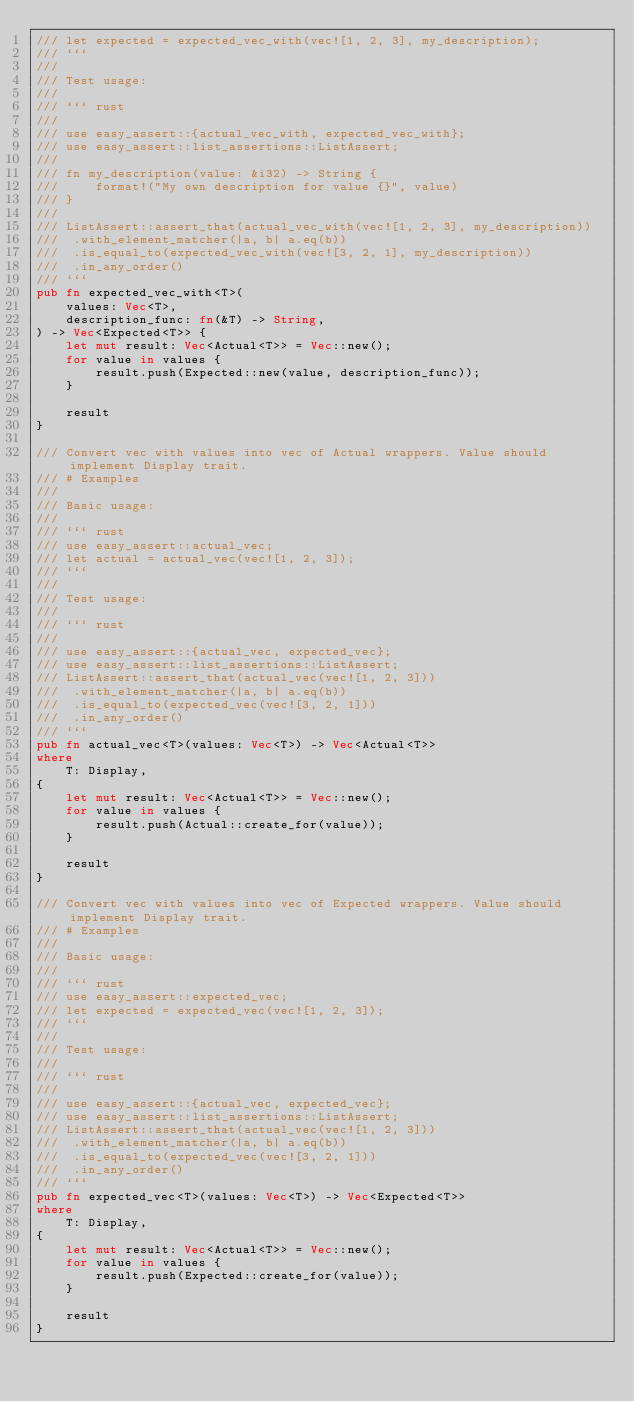<code> <loc_0><loc_0><loc_500><loc_500><_Rust_>/// let expected = expected_vec_with(vec![1, 2, 3], my_description);
/// ```
///
/// Test usage:
///
/// ``` rust
///
/// use easy_assert::{actual_vec_with, expected_vec_with};
/// use easy_assert::list_assertions::ListAssert;
///
/// fn my_description(value: &i32) -> String {
///     format!("My own description for value {}", value)
/// }
///
/// ListAssert::assert_that(actual_vec_with(vec![1, 2, 3], my_description))
///  .with_element_matcher(|a, b| a.eq(b))
///  .is_equal_to(expected_vec_with(vec![3, 2, 1], my_description))
///  .in_any_order()
/// ```
pub fn expected_vec_with<T>(
    values: Vec<T>,
    description_func: fn(&T) -> String,
) -> Vec<Expected<T>> {
    let mut result: Vec<Actual<T>> = Vec::new();
    for value in values {
        result.push(Expected::new(value, description_func));
    }

    result
}

/// Convert vec with values into vec of Actual wrappers. Value should implement Display trait.
/// # Examples
///
/// Basic usage:
///
/// ``` rust
/// use easy_assert::actual_vec;
/// let actual = actual_vec(vec![1, 2, 3]);
/// ```
///
/// Test usage:
///
/// ``` rust
///
/// use easy_assert::{actual_vec, expected_vec};
/// use easy_assert::list_assertions::ListAssert;
/// ListAssert::assert_that(actual_vec(vec![1, 2, 3]))
///  .with_element_matcher(|a, b| a.eq(b))
///  .is_equal_to(expected_vec(vec![3, 2, 1]))
///  .in_any_order()
/// ```
pub fn actual_vec<T>(values: Vec<T>) -> Vec<Actual<T>>
where
    T: Display,
{
    let mut result: Vec<Actual<T>> = Vec::new();
    for value in values {
        result.push(Actual::create_for(value));
    }

    result
}

/// Convert vec with values into vec of Expected wrappers. Value should implement Display trait.
/// # Examples
///
/// Basic usage:
///
/// ``` rust
/// use easy_assert::expected_vec;
/// let expected = expected_vec(vec![1, 2, 3]);
/// ```
///
/// Test usage:
///
/// ``` rust
///
/// use easy_assert::{actual_vec, expected_vec};
/// use easy_assert::list_assertions::ListAssert;
/// ListAssert::assert_that(actual_vec(vec![1, 2, 3]))
///  .with_element_matcher(|a, b| a.eq(b))
///  .is_equal_to(expected_vec(vec![3, 2, 1]))
///  .in_any_order()
/// ```
pub fn expected_vec<T>(values: Vec<T>) -> Vec<Expected<T>>
where
    T: Display,
{
    let mut result: Vec<Actual<T>> = Vec::new();
    for value in values {
        result.push(Expected::create_for(value));
    }

    result
}
</code> 